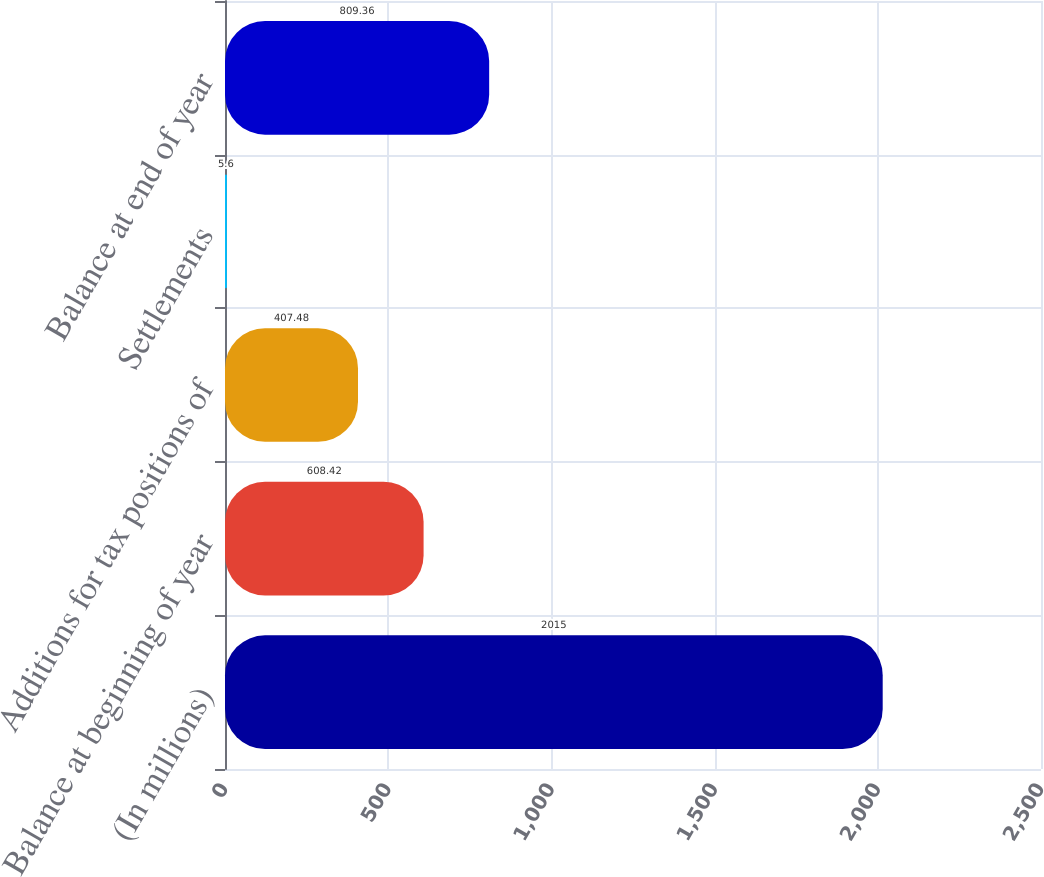Convert chart to OTSL. <chart><loc_0><loc_0><loc_500><loc_500><bar_chart><fcel>(In millions)<fcel>Balance at beginning of year<fcel>Additions for tax positions of<fcel>Settlements<fcel>Balance at end of year<nl><fcel>2015<fcel>608.42<fcel>407.48<fcel>5.6<fcel>809.36<nl></chart> 